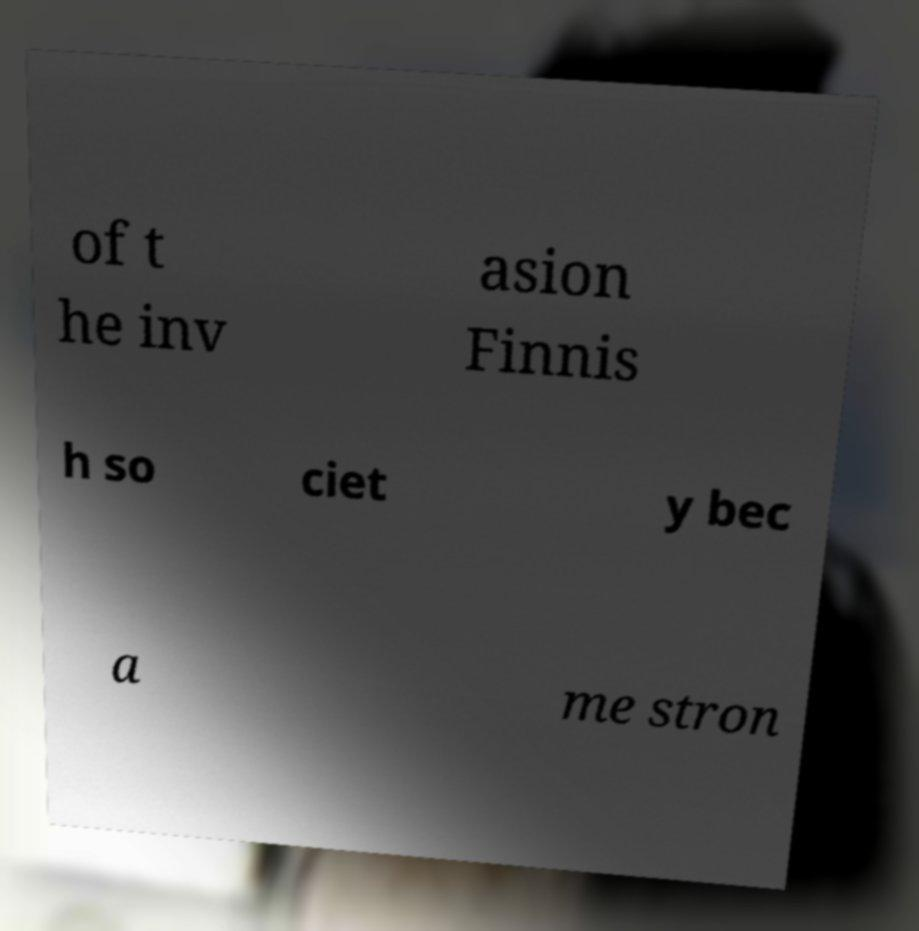Could you extract and type out the text from this image? of t he inv asion Finnis h so ciet y bec a me stron 